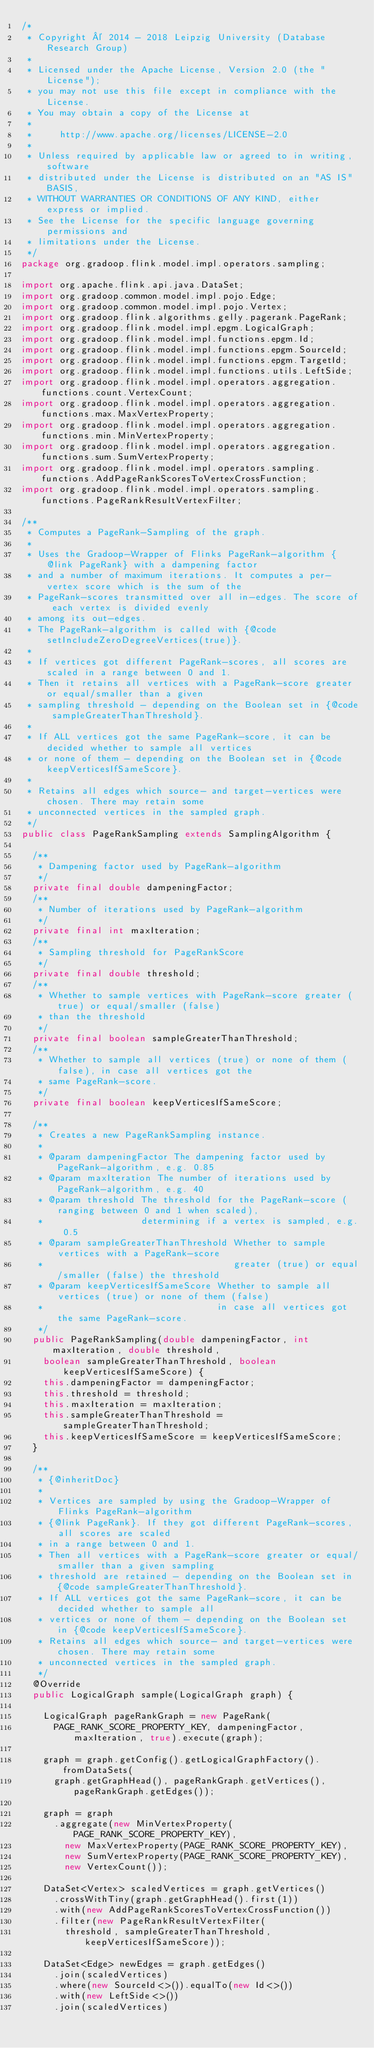Convert code to text. <code><loc_0><loc_0><loc_500><loc_500><_Java_>/*
 * Copyright © 2014 - 2018 Leipzig University (Database Research Group)
 *
 * Licensed under the Apache License, Version 2.0 (the "License");
 * you may not use this file except in compliance with the License.
 * You may obtain a copy of the License at
 *
 *     http://www.apache.org/licenses/LICENSE-2.0
 *
 * Unless required by applicable law or agreed to in writing, software
 * distributed under the License is distributed on an "AS IS" BASIS,
 * WITHOUT WARRANTIES OR CONDITIONS OF ANY KIND, either express or implied.
 * See the License for the specific language governing permissions and
 * limitations under the License.
 */
package org.gradoop.flink.model.impl.operators.sampling;

import org.apache.flink.api.java.DataSet;
import org.gradoop.common.model.impl.pojo.Edge;
import org.gradoop.common.model.impl.pojo.Vertex;
import org.gradoop.flink.algorithms.gelly.pagerank.PageRank;
import org.gradoop.flink.model.impl.epgm.LogicalGraph;
import org.gradoop.flink.model.impl.functions.epgm.Id;
import org.gradoop.flink.model.impl.functions.epgm.SourceId;
import org.gradoop.flink.model.impl.functions.epgm.TargetId;
import org.gradoop.flink.model.impl.functions.utils.LeftSide;
import org.gradoop.flink.model.impl.operators.aggregation.functions.count.VertexCount;
import org.gradoop.flink.model.impl.operators.aggregation.functions.max.MaxVertexProperty;
import org.gradoop.flink.model.impl.operators.aggregation.functions.min.MinVertexProperty;
import org.gradoop.flink.model.impl.operators.aggregation.functions.sum.SumVertexProperty;
import org.gradoop.flink.model.impl.operators.sampling.functions.AddPageRankScoresToVertexCrossFunction;
import org.gradoop.flink.model.impl.operators.sampling.functions.PageRankResultVertexFilter;

/**
 * Computes a PageRank-Sampling of the graph.
 *
 * Uses the Gradoop-Wrapper of Flinks PageRank-algorithm {@link PageRank} with a dampening factor
 * and a number of maximum iterations. It computes a per-vertex score which is the sum of the
 * PageRank-scores transmitted over all in-edges. The score of each vertex is divided evenly
 * among its out-edges.
 * The PageRank-algorithm is called with {@code setIncludeZeroDegreeVertices(true)}.
 *
 * If vertices got different PageRank-scores, all scores are scaled in a range between 0 and 1.
 * Then it retains all vertices with a PageRank-score greater or equal/smaller than a given
 * sampling threshold - depending on the Boolean set in {@code sampleGreaterThanThreshold}.
 *
 * If ALL vertices got the same PageRank-score, it can be decided whether to sample all vertices
 * or none of them - depending on the Boolean set in {@code keepVerticesIfSameScore}.
 *
 * Retains all edges which source- and target-vertices were chosen. There may retain some
 * unconnected vertices in the sampled graph.
 */
public class PageRankSampling extends SamplingAlgorithm {

  /**
   * Dampening factor used by PageRank-algorithm
   */
  private final double dampeningFactor;
  /**
   * Number of iterations used by PageRank-algorithm
   */
  private final int maxIteration;
  /**
   * Sampling threshold for PageRankScore
   */
  private final double threshold;
  /**
   * Whether to sample vertices with PageRank-score greater (true) or equal/smaller (false)
   * than the threshold
   */
  private final boolean sampleGreaterThanThreshold;
  /**
   * Whether to sample all vertices (true) or none of them (false), in case all vertices got the
   * same PageRank-score.
   */
  private final boolean keepVerticesIfSameScore;

  /**
   * Creates a new PageRankSampling instance.
   *
   * @param dampeningFactor The dampening factor used by PageRank-algorithm, e.g. 0.85
   * @param maxIteration The number of iterations used by PageRank-algorithm, e.g. 40
   * @param threshold The threshold for the PageRank-score (ranging between 0 and 1 when scaled),
   *                  determining if a vertex is sampled, e.g. 0.5
   * @param sampleGreaterThanThreshold Whether to sample vertices with a PageRank-score
   *                                   greater (true) or equal/smaller (false) the threshold
   * @param keepVerticesIfSameScore Whether to sample all vertices (true) or none of them (false)
   *                                in case all vertices got the same PageRank-score.
   */
  public PageRankSampling(double dampeningFactor, int maxIteration, double threshold,
    boolean sampleGreaterThanThreshold, boolean keepVerticesIfSameScore) {
    this.dampeningFactor = dampeningFactor;
    this.threshold = threshold;
    this.maxIteration = maxIteration;
    this.sampleGreaterThanThreshold = sampleGreaterThanThreshold;
    this.keepVerticesIfSameScore = keepVerticesIfSameScore;
  }

  /**
   * {@inheritDoc}
   *
   * Vertices are sampled by using the Gradoop-Wrapper of Flinks PageRank-algorithm
   * {@link PageRank}. If they got different PageRank-scores, all scores are scaled
   * in a range between 0 and 1.
   * Then all vertices with a PageRank-score greater or equal/smaller than a given sampling
   * threshold are retained - depending on the Boolean set in {@code sampleGreaterThanThreshold}.
   * If ALL vertices got the same PageRank-score, it can be decided whether to sample all
   * vertices or none of them - depending on the Boolean set in {@code keepVerticesIfSameScore}.
   * Retains all edges which source- and target-vertices were chosen. There may retain some
   * unconnected vertices in the sampled graph.
   */
  @Override
  public LogicalGraph sample(LogicalGraph graph) {

    LogicalGraph pageRankGraph = new PageRank(
      PAGE_RANK_SCORE_PROPERTY_KEY, dampeningFactor, maxIteration, true).execute(graph);

    graph = graph.getConfig().getLogicalGraphFactory().fromDataSets(
      graph.getGraphHead(), pageRankGraph.getVertices(), pageRankGraph.getEdges());

    graph = graph
      .aggregate(new MinVertexProperty(PAGE_RANK_SCORE_PROPERTY_KEY),
        new MaxVertexProperty(PAGE_RANK_SCORE_PROPERTY_KEY),
        new SumVertexProperty(PAGE_RANK_SCORE_PROPERTY_KEY),
        new VertexCount());

    DataSet<Vertex> scaledVertices = graph.getVertices()
      .crossWithTiny(graph.getGraphHead().first(1))
      .with(new AddPageRankScoresToVertexCrossFunction())
      .filter(new PageRankResultVertexFilter(
        threshold, sampleGreaterThanThreshold, keepVerticesIfSameScore));

    DataSet<Edge> newEdges = graph.getEdges()
      .join(scaledVertices)
      .where(new SourceId<>()).equalTo(new Id<>())
      .with(new LeftSide<>())
      .join(scaledVertices)</code> 